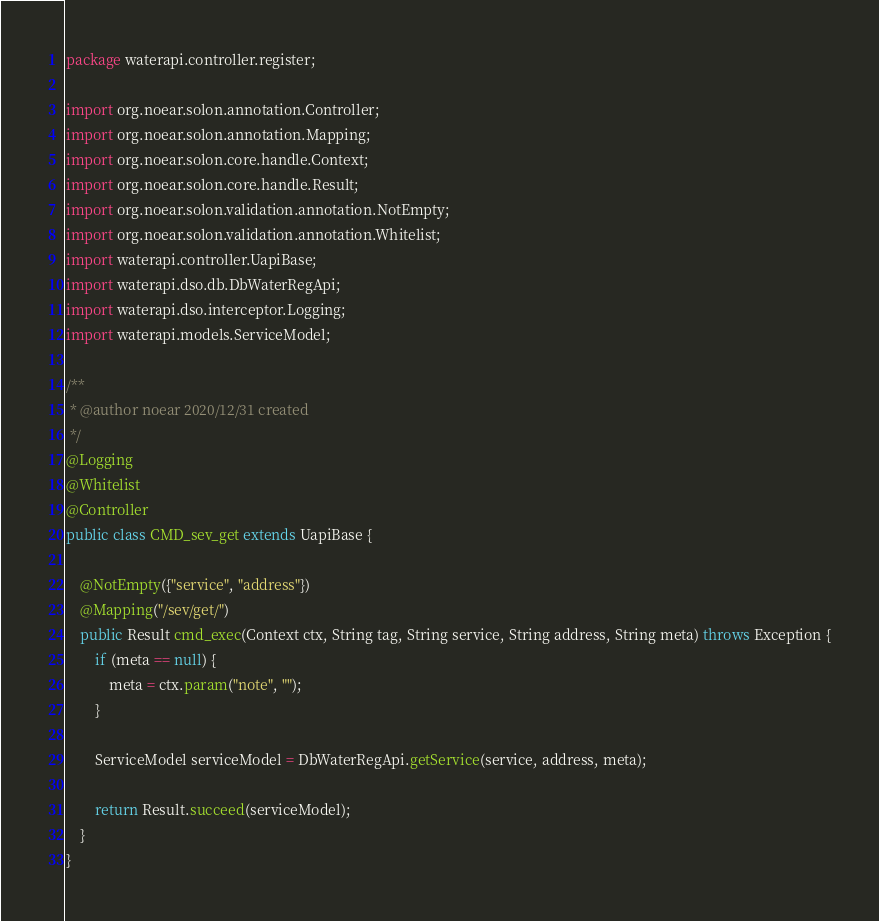<code> <loc_0><loc_0><loc_500><loc_500><_Java_>package waterapi.controller.register;

import org.noear.solon.annotation.Controller;
import org.noear.solon.annotation.Mapping;
import org.noear.solon.core.handle.Context;
import org.noear.solon.core.handle.Result;
import org.noear.solon.validation.annotation.NotEmpty;
import org.noear.solon.validation.annotation.Whitelist;
import waterapi.controller.UapiBase;
import waterapi.dso.db.DbWaterRegApi;
import waterapi.dso.interceptor.Logging;
import waterapi.models.ServiceModel;

/**
 * @author noear 2020/12/31 created
 */
@Logging
@Whitelist
@Controller
public class CMD_sev_get extends UapiBase {

    @NotEmpty({"service", "address"})
    @Mapping("/sev/get/")
    public Result cmd_exec(Context ctx, String tag, String service, String address, String meta) throws Exception {
        if (meta == null) {
            meta = ctx.param("note", "");
        }

        ServiceModel serviceModel = DbWaterRegApi.getService(service, address, meta);

        return Result.succeed(serviceModel);
    }
}
</code> 